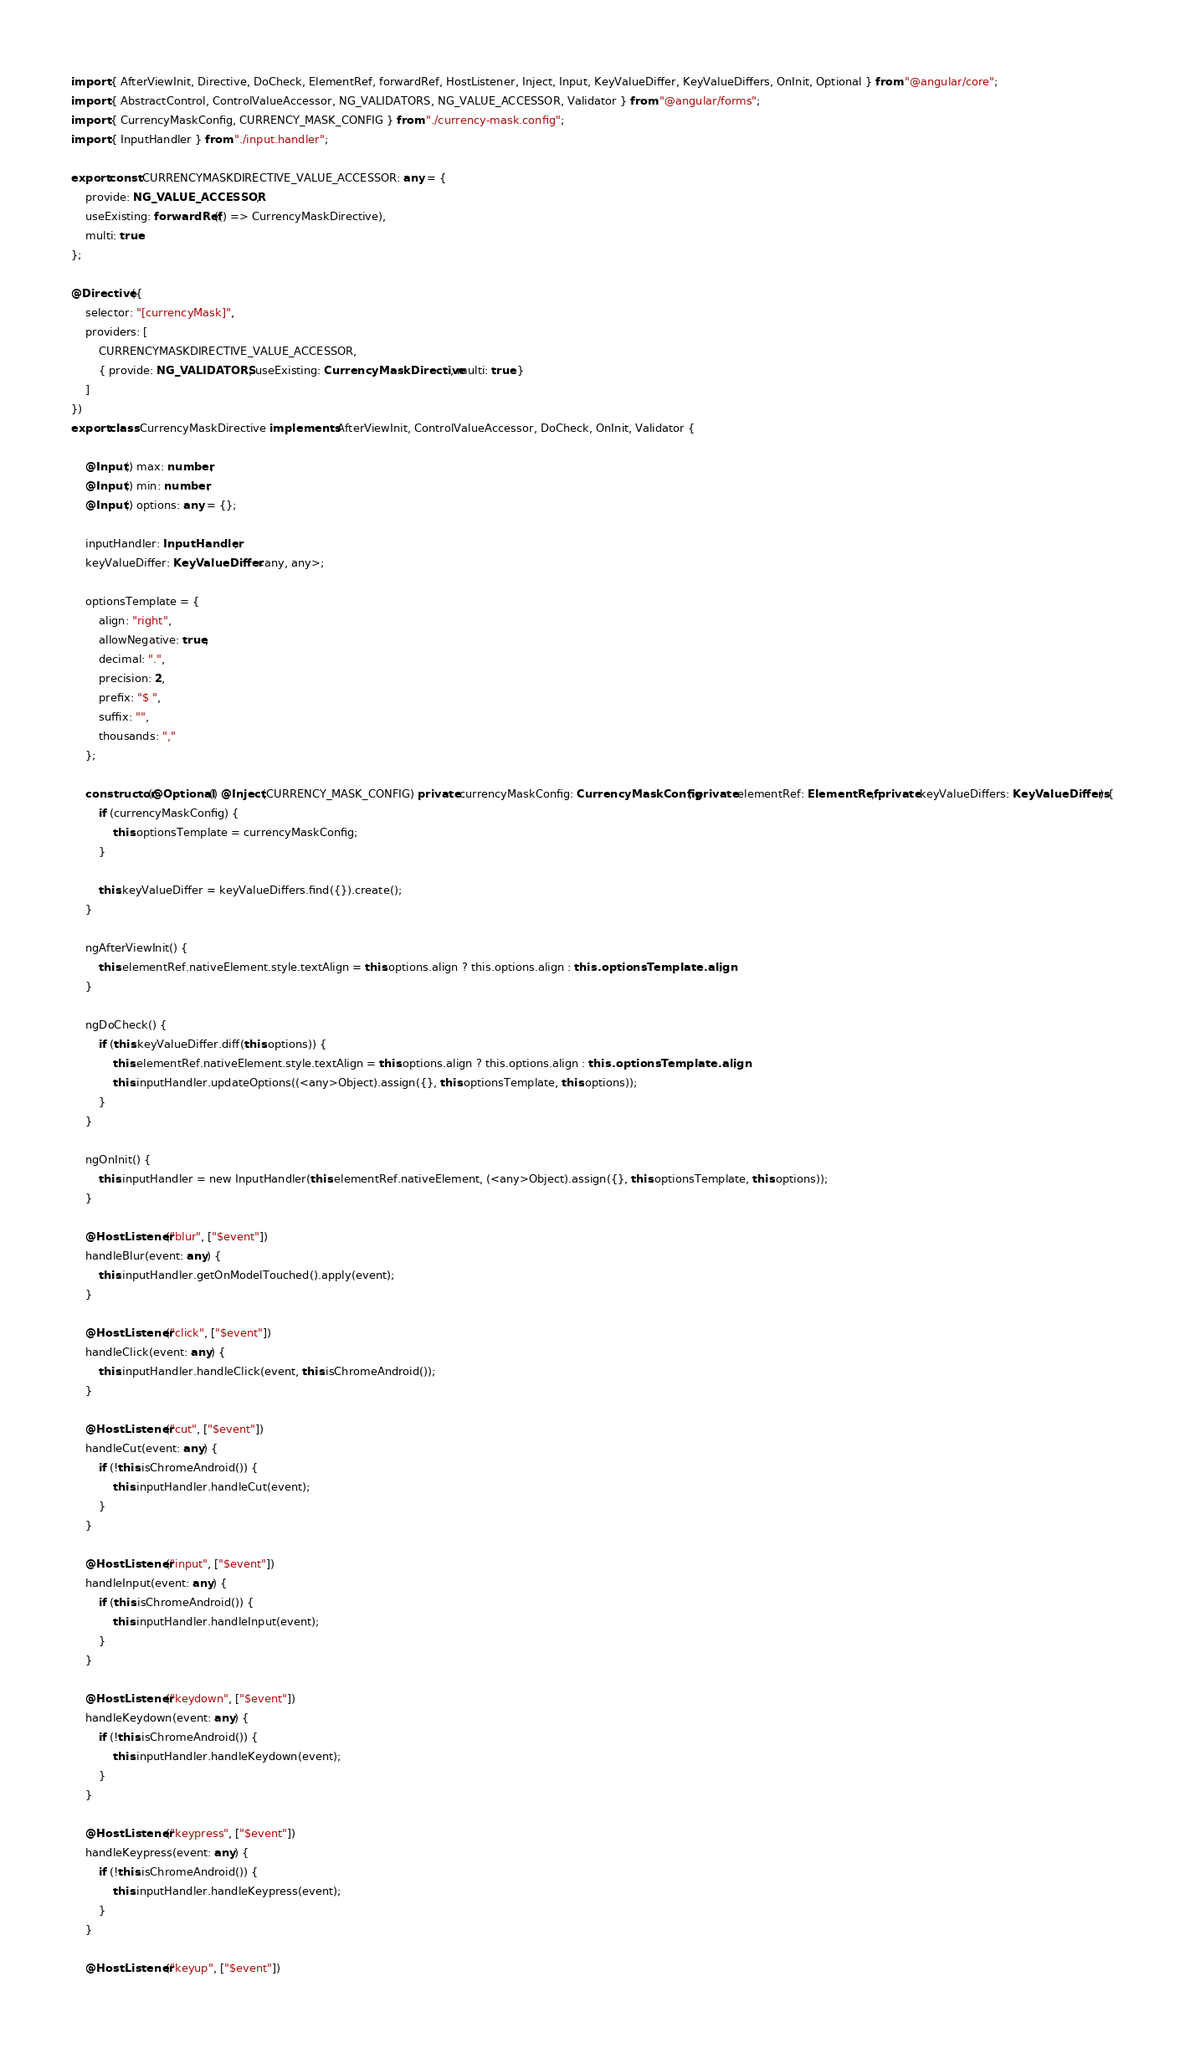Convert code to text. <code><loc_0><loc_0><loc_500><loc_500><_TypeScript_>import { AfterViewInit, Directive, DoCheck, ElementRef, forwardRef, HostListener, Inject, Input, KeyValueDiffer, KeyValueDiffers, OnInit, Optional } from "@angular/core";
import { AbstractControl, ControlValueAccessor, NG_VALIDATORS, NG_VALUE_ACCESSOR, Validator } from "@angular/forms";
import { CurrencyMaskConfig, CURRENCY_MASK_CONFIG } from "./currency-mask.config";
import { InputHandler } from "./input.handler";

export const CURRENCYMASKDIRECTIVE_VALUE_ACCESSOR: any = {
    provide: NG_VALUE_ACCESSOR,
    useExisting: forwardRef(() => CurrencyMaskDirective),
    multi: true
};

@Directive({
    selector: "[currencyMask]",
    providers: [
        CURRENCYMASKDIRECTIVE_VALUE_ACCESSOR,
        { provide: NG_VALIDATORS, useExisting: CurrencyMaskDirective, multi: true }
    ]
})
export class CurrencyMaskDirective implements AfterViewInit, ControlValueAccessor, DoCheck, OnInit, Validator {

    @Input() max: number;
    @Input() min: number;
    @Input() options: any = {};

    inputHandler: InputHandler;
    keyValueDiffer: KeyValueDiffer<any, any>;

    optionsTemplate = {
        align: "right",
        allowNegative: true,
        decimal: ".",
        precision: 2,
        prefix: "$ ",
        suffix: "",
        thousands: ","
    };

    constructor(@Optional() @Inject(CURRENCY_MASK_CONFIG) private currencyMaskConfig: CurrencyMaskConfig, private elementRef: ElementRef, private keyValueDiffers: KeyValueDiffers) {
        if (currencyMaskConfig) {
            this.optionsTemplate = currencyMaskConfig;
        }

        this.keyValueDiffer = keyValueDiffers.find({}).create();
    }

    ngAfterViewInit() {
        this.elementRef.nativeElement.style.textAlign = this.options.align ? this.options.align : this.optionsTemplate.align;
    }

    ngDoCheck() {
        if (this.keyValueDiffer.diff(this.options)) {
            this.elementRef.nativeElement.style.textAlign = this.options.align ? this.options.align : this.optionsTemplate.align;
            this.inputHandler.updateOptions((<any>Object).assign({}, this.optionsTemplate, this.options));
        }
    }

    ngOnInit() {
        this.inputHandler = new InputHandler(this.elementRef.nativeElement, (<any>Object).assign({}, this.optionsTemplate, this.options));
    }

    @HostListener("blur", ["$event"])
    handleBlur(event: any) {
        this.inputHandler.getOnModelTouched().apply(event);
    }

    @HostListener("click", ["$event"])
    handleClick(event: any) {
        this.inputHandler.handleClick(event, this.isChromeAndroid());
    }

    @HostListener("cut", ["$event"])
    handleCut(event: any) {
        if (!this.isChromeAndroid()) {
            this.inputHandler.handleCut(event);
        }
    }

    @HostListener("input", ["$event"])
    handleInput(event: any) {
        if (this.isChromeAndroid()) {
            this.inputHandler.handleInput(event);
        }
    }

    @HostListener("keydown", ["$event"])
    handleKeydown(event: any) {
        if (!this.isChromeAndroid()) {
            this.inputHandler.handleKeydown(event);
        }
    }

    @HostListener("keypress", ["$event"])
    handleKeypress(event: any) {
        if (!this.isChromeAndroid()) {
            this.inputHandler.handleKeypress(event);
        }
    }

    @HostListener("keyup", ["$event"])</code> 